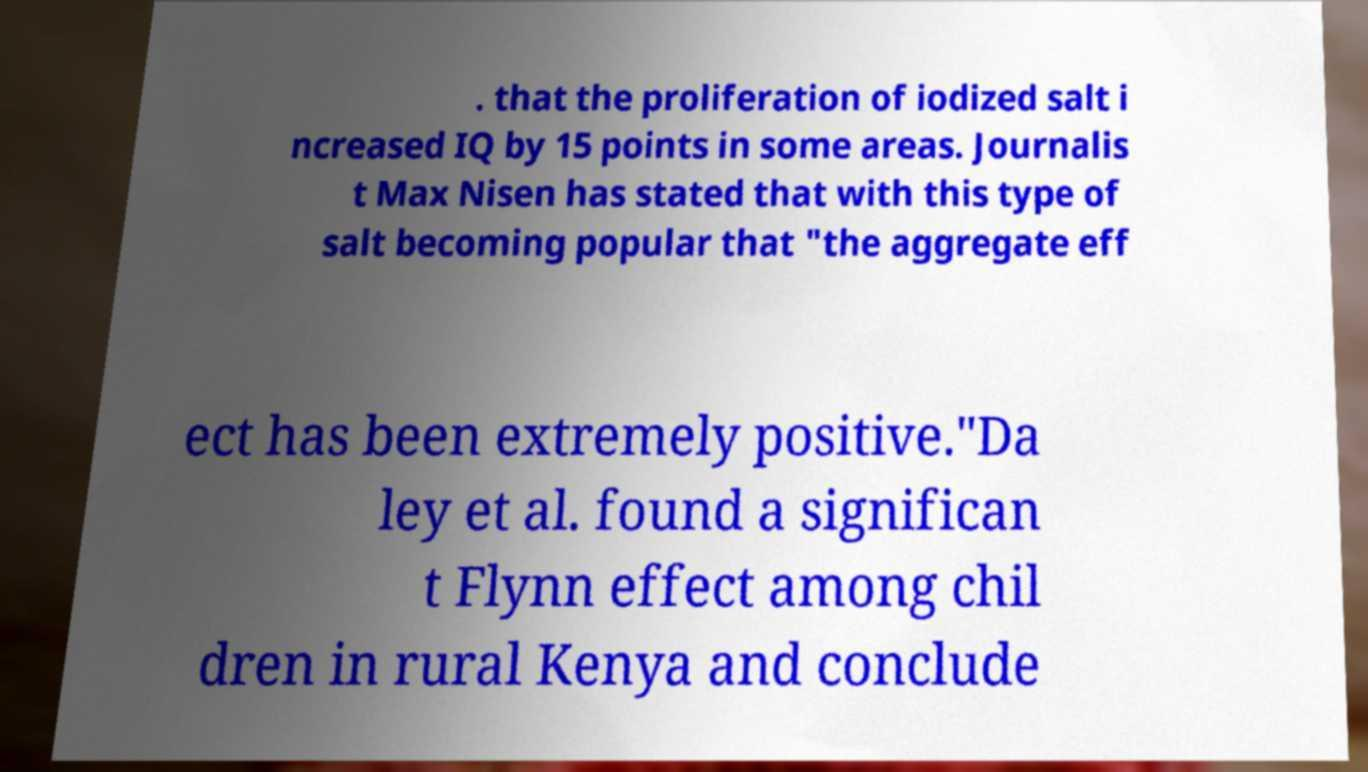Please identify and transcribe the text found in this image. . that the proliferation of iodized salt i ncreased IQ by 15 points in some areas. Journalis t Max Nisen has stated that with this type of salt becoming popular that "the aggregate eff ect has been extremely positive."Da ley et al. found a significan t Flynn effect among chil dren in rural Kenya and conclude 